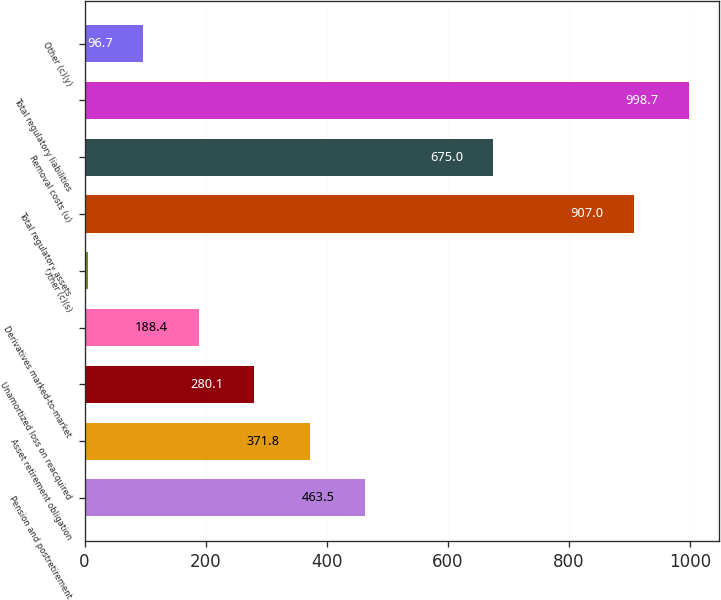Convert chart. <chart><loc_0><loc_0><loc_500><loc_500><bar_chart><fcel>Pension and postretirement<fcel>Asset retirement obligation<fcel>Unamortized loss on reacquired<fcel>Derivatives marked-to-market<fcel>Other (c)(s)<fcel>Total regulatory assets<fcel>Removal costs (u)<fcel>Total regulatory liabilities<fcel>Other (c)(y)<nl><fcel>463.5<fcel>371.8<fcel>280.1<fcel>188.4<fcel>5<fcel>907<fcel>675<fcel>998.7<fcel>96.7<nl></chart> 